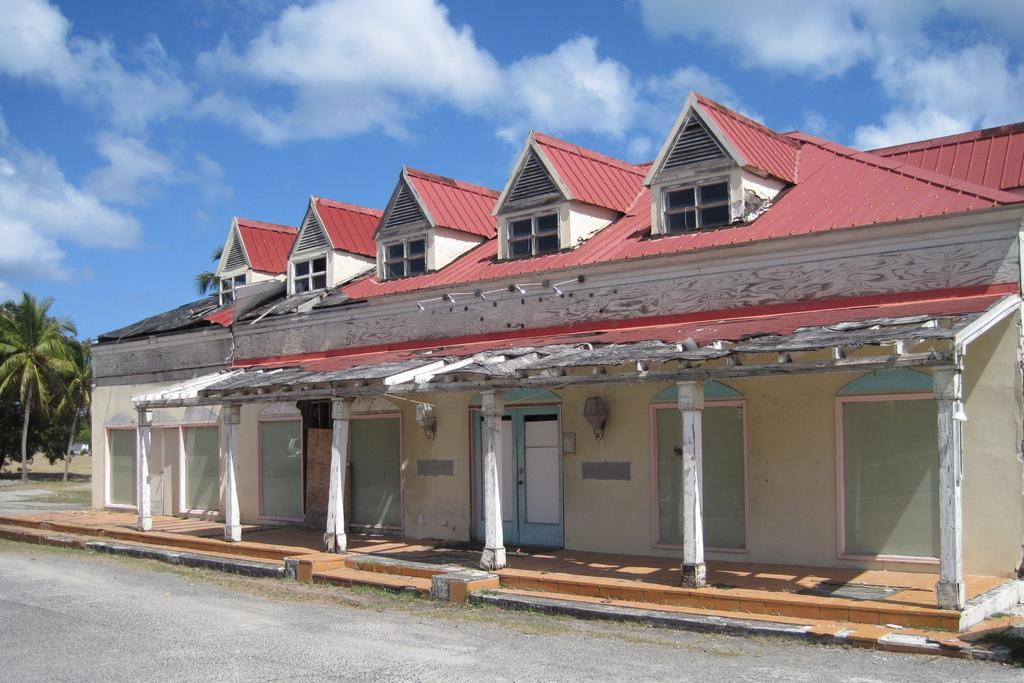What type of structure is present in the image? There is a house in the image. What are some features of the house? The house has doors, pillars, and a red color roof. What else can be seen in the image besides the house? There is a road, trees, and the sky in the background. Can you describe the sky in the image? The sky is blue in the background, and there are clouds present. What type of string is used to hold the territory in the image? There is no territory or string present in the image. What angle can be seen in the image? The image does not depict any angles; it is a photograph of a house, road, trees, and sky. 